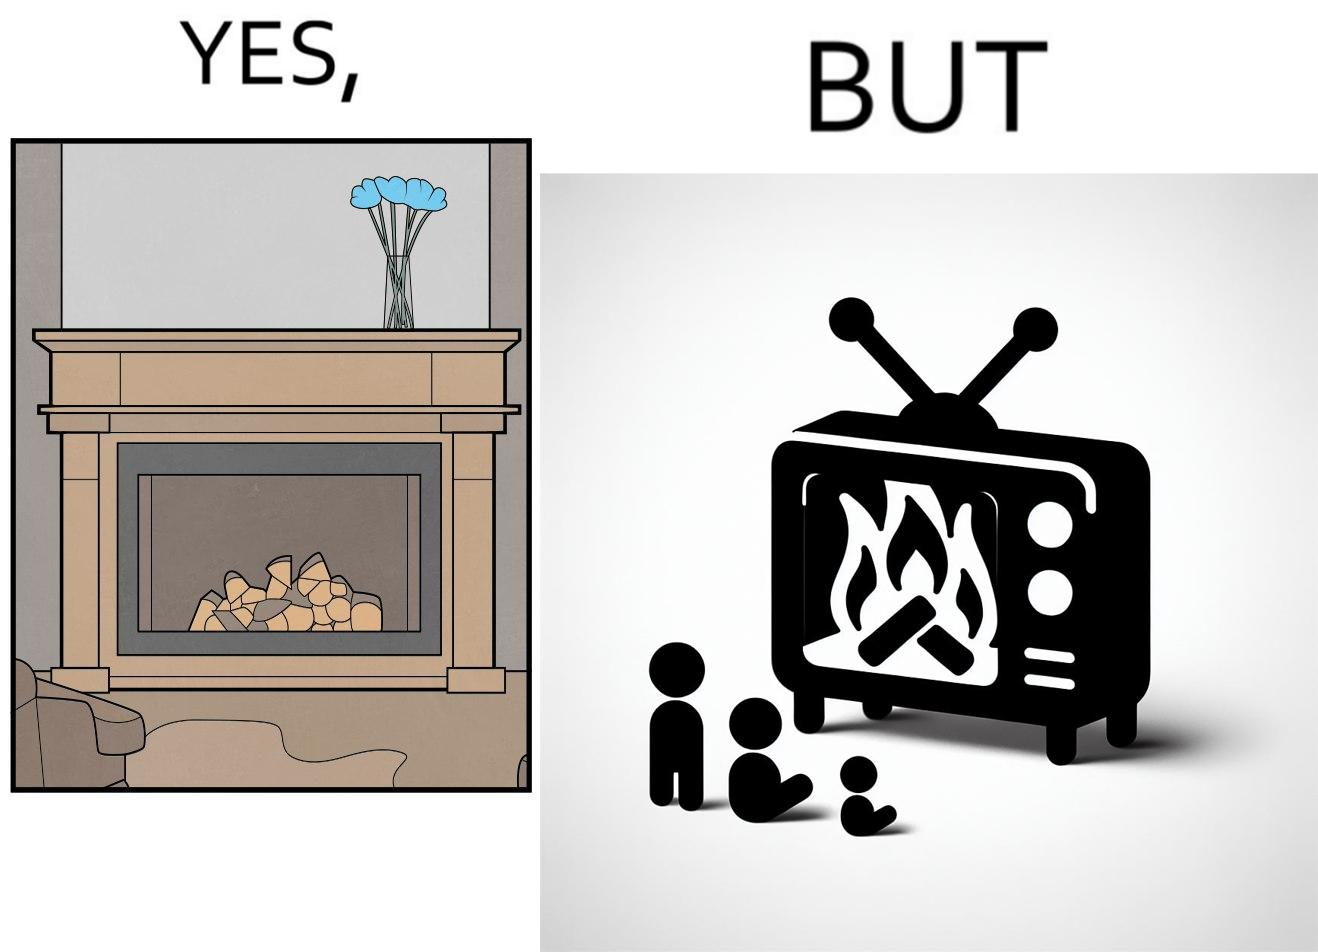Would you classify this image as satirical? Yes, this image is satirical. 